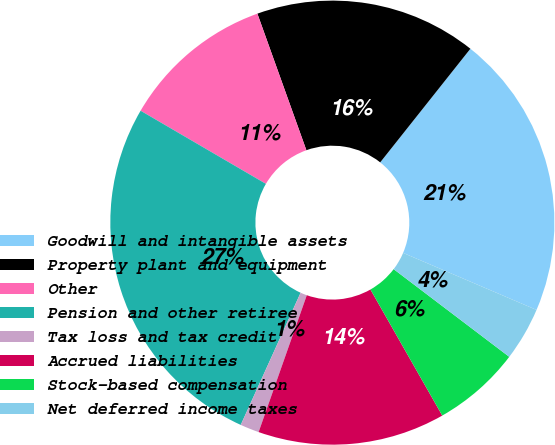<chart> <loc_0><loc_0><loc_500><loc_500><pie_chart><fcel>Goodwill and intangible assets<fcel>Property plant and equipment<fcel>Other<fcel>Pension and other retiree<fcel>Tax loss and tax credit<fcel>Accrued liabilities<fcel>Stock-based compensation<fcel>Net deferred income taxes<nl><fcel>20.75%<fcel>16.16%<fcel>11.11%<fcel>26.64%<fcel>1.38%<fcel>13.63%<fcel>6.43%<fcel>3.9%<nl></chart> 